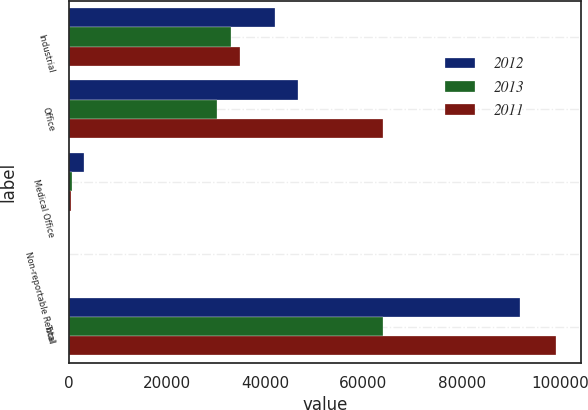Convert chart to OTSL. <chart><loc_0><loc_0><loc_500><loc_500><stacked_bar_chart><ecel><fcel>Industrial<fcel>Office<fcel>Medical Office<fcel>Non-reportable Rental<fcel>Total<nl><fcel>2012<fcel>41971<fcel>46600<fcel>3106<fcel>121<fcel>91798<nl><fcel>2013<fcel>33095<fcel>30092<fcel>641<fcel>56<fcel>63884<nl><fcel>2011<fcel>34872<fcel>63933<fcel>410<fcel>49<fcel>99264<nl></chart> 